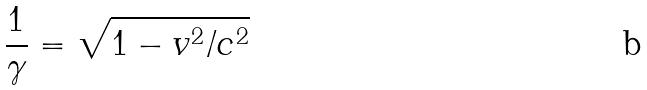<formula> <loc_0><loc_0><loc_500><loc_500>\frac { 1 } { \gamma } = \sqrt { 1 - v ^ { 2 } / c ^ { 2 } }</formula> 